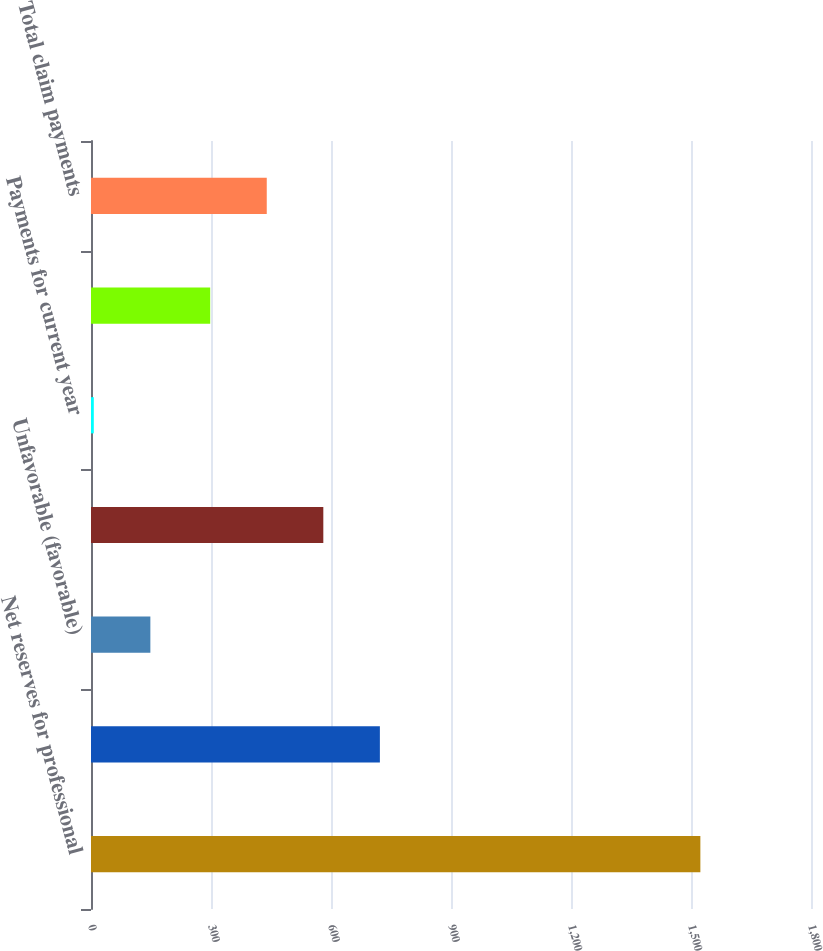<chart> <loc_0><loc_0><loc_500><loc_500><bar_chart><fcel>Net reserves for professional<fcel>Provision for current year<fcel>Unfavorable (favorable)<fcel>Total provision<fcel>Payments for current year<fcel>Payments for prior years'<fcel>Total claim payments<nl><fcel>1523.4<fcel>722.2<fcel>148.4<fcel>580.8<fcel>7<fcel>298<fcel>439.4<nl></chart> 